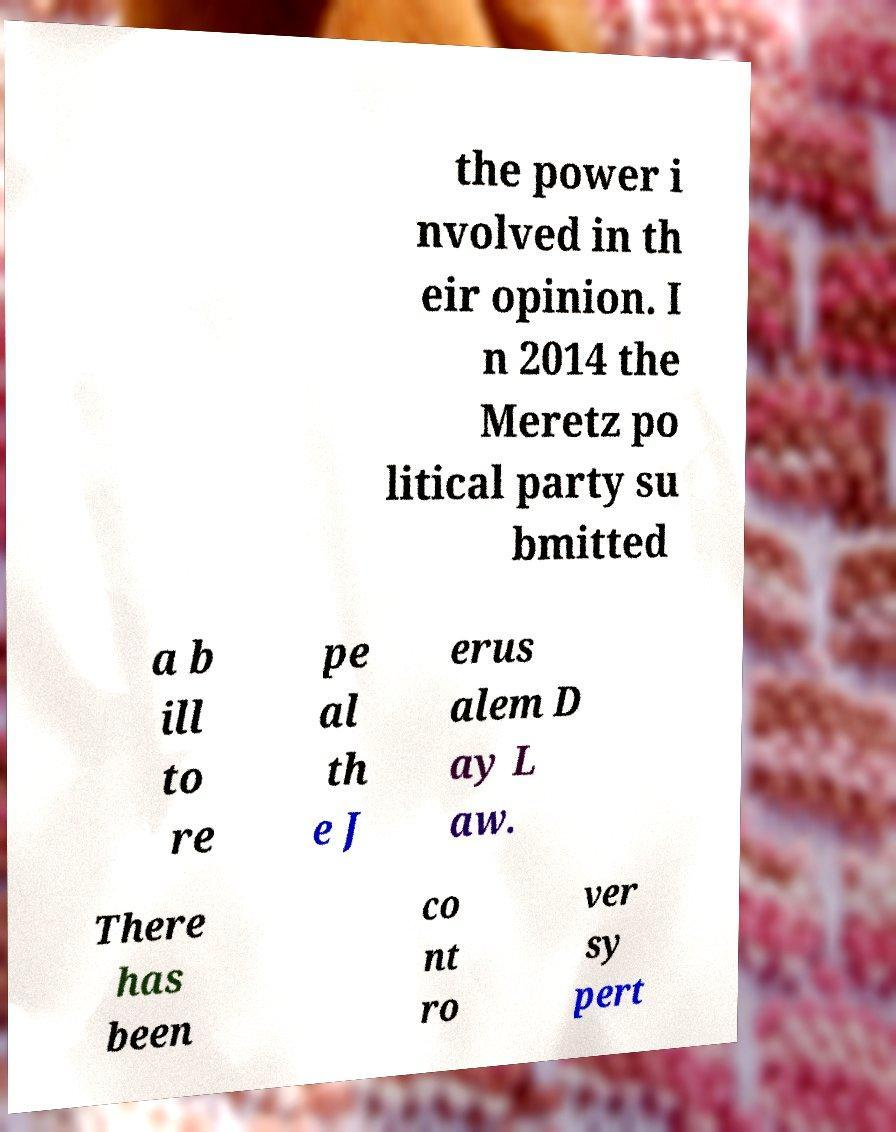Could you extract and type out the text from this image? the power i nvolved in th eir opinion. I n 2014 the Meretz po litical party su bmitted a b ill to re pe al th e J erus alem D ay L aw. There has been co nt ro ver sy pert 